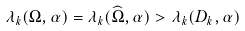<formula> <loc_0><loc_0><loc_500><loc_500>\lambda _ { k } ( \Omega , \alpha ) = \lambda _ { k } ( \widehat { \Omega } , \alpha ) > \lambda _ { k } ( D _ { k } , \alpha )</formula> 